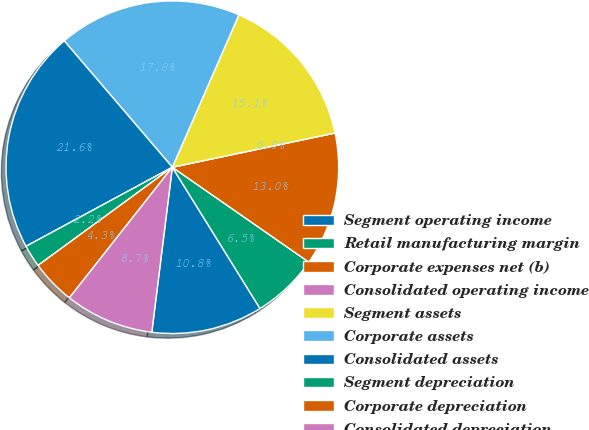<chart> <loc_0><loc_0><loc_500><loc_500><pie_chart><fcel>Segment operating income<fcel>Retail manufacturing margin<fcel>Corporate expenses net (b)<fcel>Consolidated operating income<fcel>Segment assets<fcel>Corporate assets<fcel>Consolidated assets<fcel>Segment depreciation<fcel>Corporate depreciation<fcel>Consolidated depreciation<nl><fcel>10.81%<fcel>6.49%<fcel>12.97%<fcel>0.0%<fcel>15.14%<fcel>17.82%<fcel>21.62%<fcel>2.16%<fcel>4.33%<fcel>8.65%<nl></chart> 